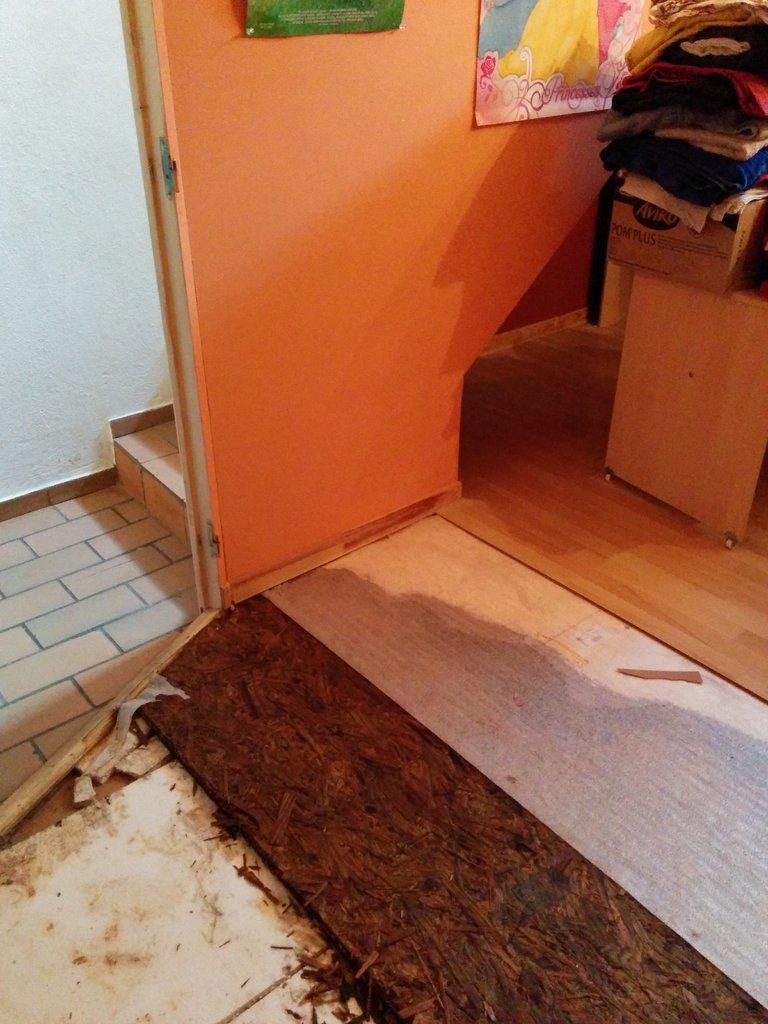How would you summarize this image in a sentence or two? In this image posters are attached to the wall. Right side there is a table having a box. On the box there are clothes which are kept one upon the other. Bottom of the image there is some trash on the floor. 